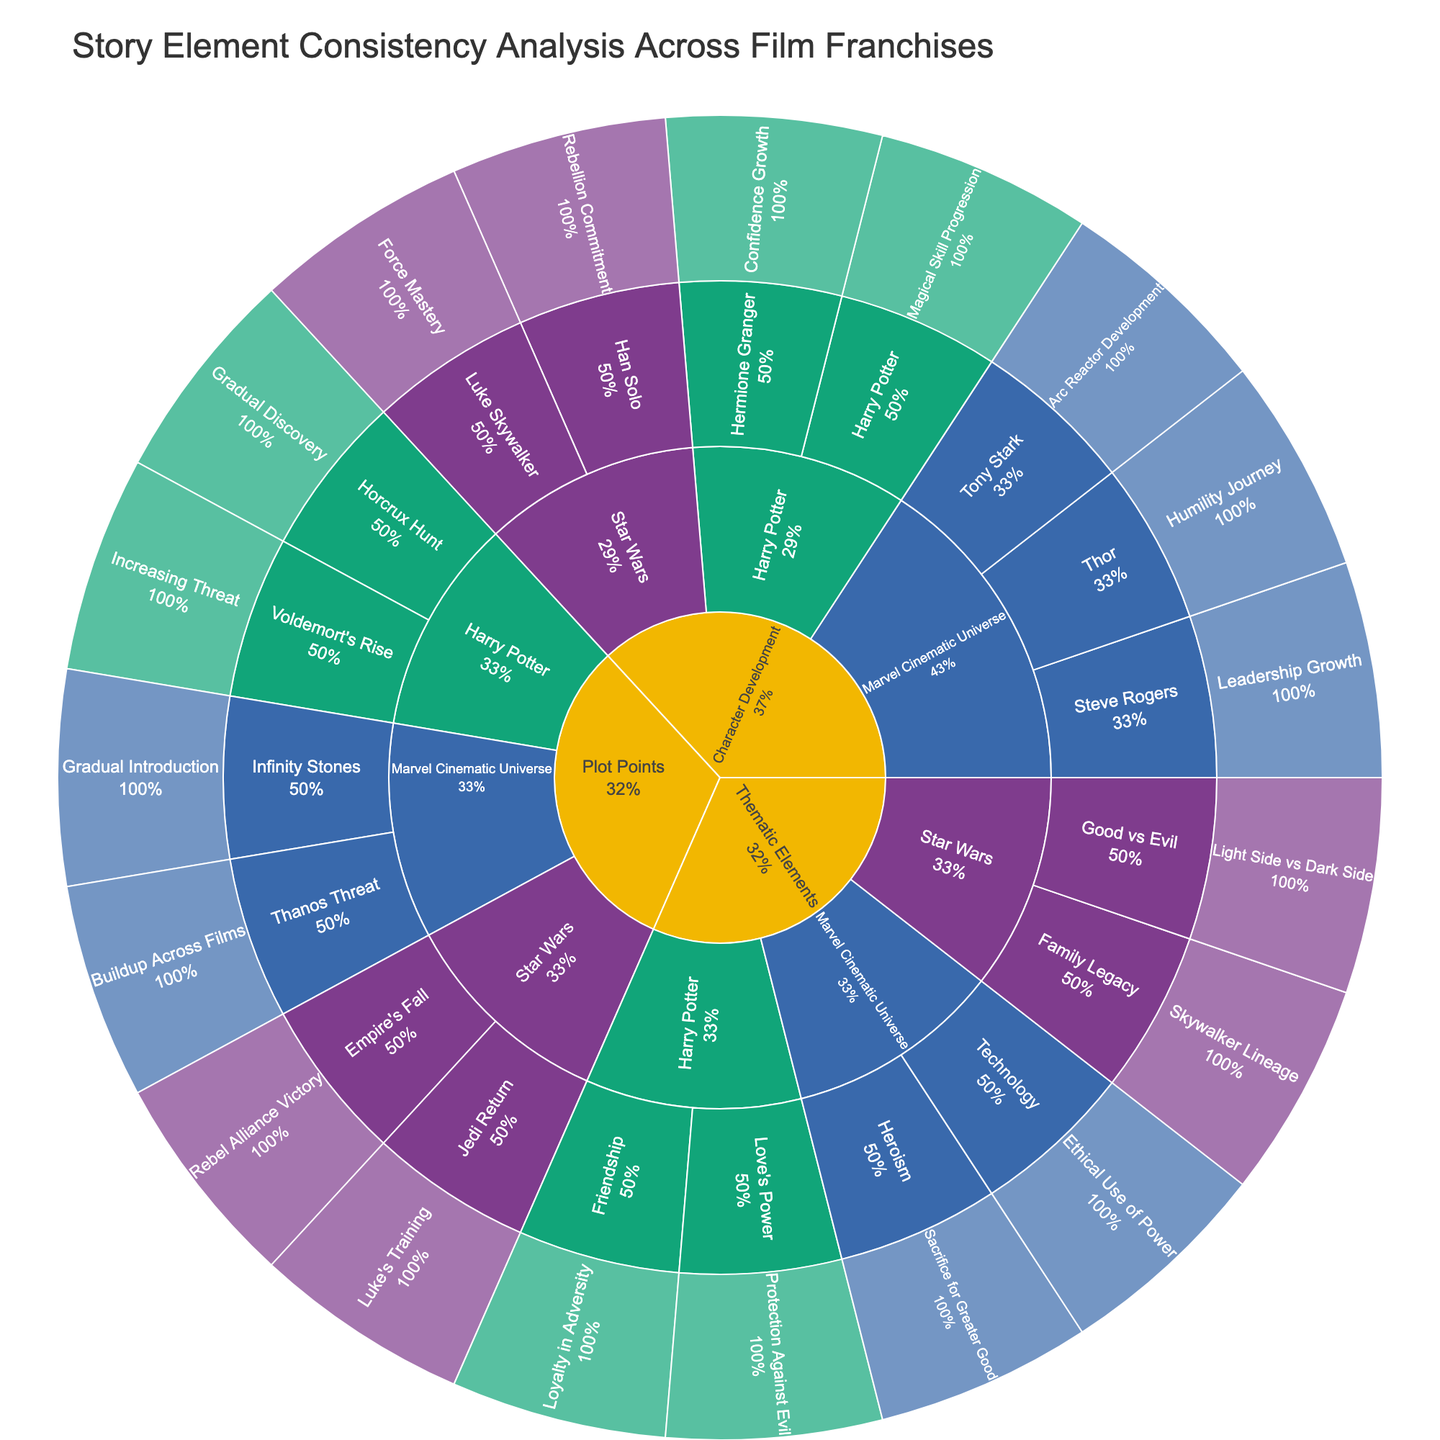What is the title of the figure? The title of the figure is usually located at the top center in a larger font size than the rest of the text. It summarizes the overall content and purpose of the figure.
Answer: Story Element Consistency Analysis Across Film Franchises Which franchise has more character development details depicted? To determine this, look at the number of specific details under the "Character Development" category for each franchise. Compare the counts for each.
Answer: Marvel Cinematic Universe What percentage of thematic elements in the Harry Potter franchise is about "Love's Power"? Find the section under "Thematic Elements" for the Harry Potter franchise. Then observe the percentage next to "Love's Power" within this section, which is provided in the figure.
Answer: 50% Which film franchise has the theme of "Ethical Use of Power"? Locate the "Thematic Elements" category and identify the "Ethical Use of Power" theme, then trace it upwards to see which franchise it belongs to.
Answer: Marvel Cinematic Universe Compare the number of plot points detailed for the Marvel Cinematic Universe and Star Wars franchises. Which has more? Count the number of plot points listed under each respective franchise within the "Plot Points" category. Compare these counts to see which franchisecast
Answer: Marvel Cinematic Universe has 2 plot points, while Star Wars also has 2 plot points. Both are equal Is "Skywalker Lineage" related to character development, plot points, or thematic elements? Locate "Skywalker Lineage" in the figure and see which top-level category it falls under, whether it is "Character Development," "Plot Points," or "Thematic Elements."
Answer: Thematic Elements In which franchise is the plot point "Gradual Discovery of Horcrux Hunt" found? Find the plot point titled "Gradual Discovery of Horcrux Hunt" in the figure, then trace up to see which franchise it belongs to.
Answer: Harry Potter What is the relationship between "Force Mastery" and "Jedi Return" in the Star Wars franchise? Observe the positions of "Force Mastery" and "Jedi Return" within the Star Wars section and check if they fall under different categories (e.g., character development and plot points).
Answer: "Force Mastery" is character development, while "Jedi Return" is a plot point In the Marvel Cinematic Universe, which character's development is associated with "Humility Journey"? Identify the character with the development detail "Humility Journey" within the Marvel Cinematic Universe's "Character Development" category.
Answer: Thor 